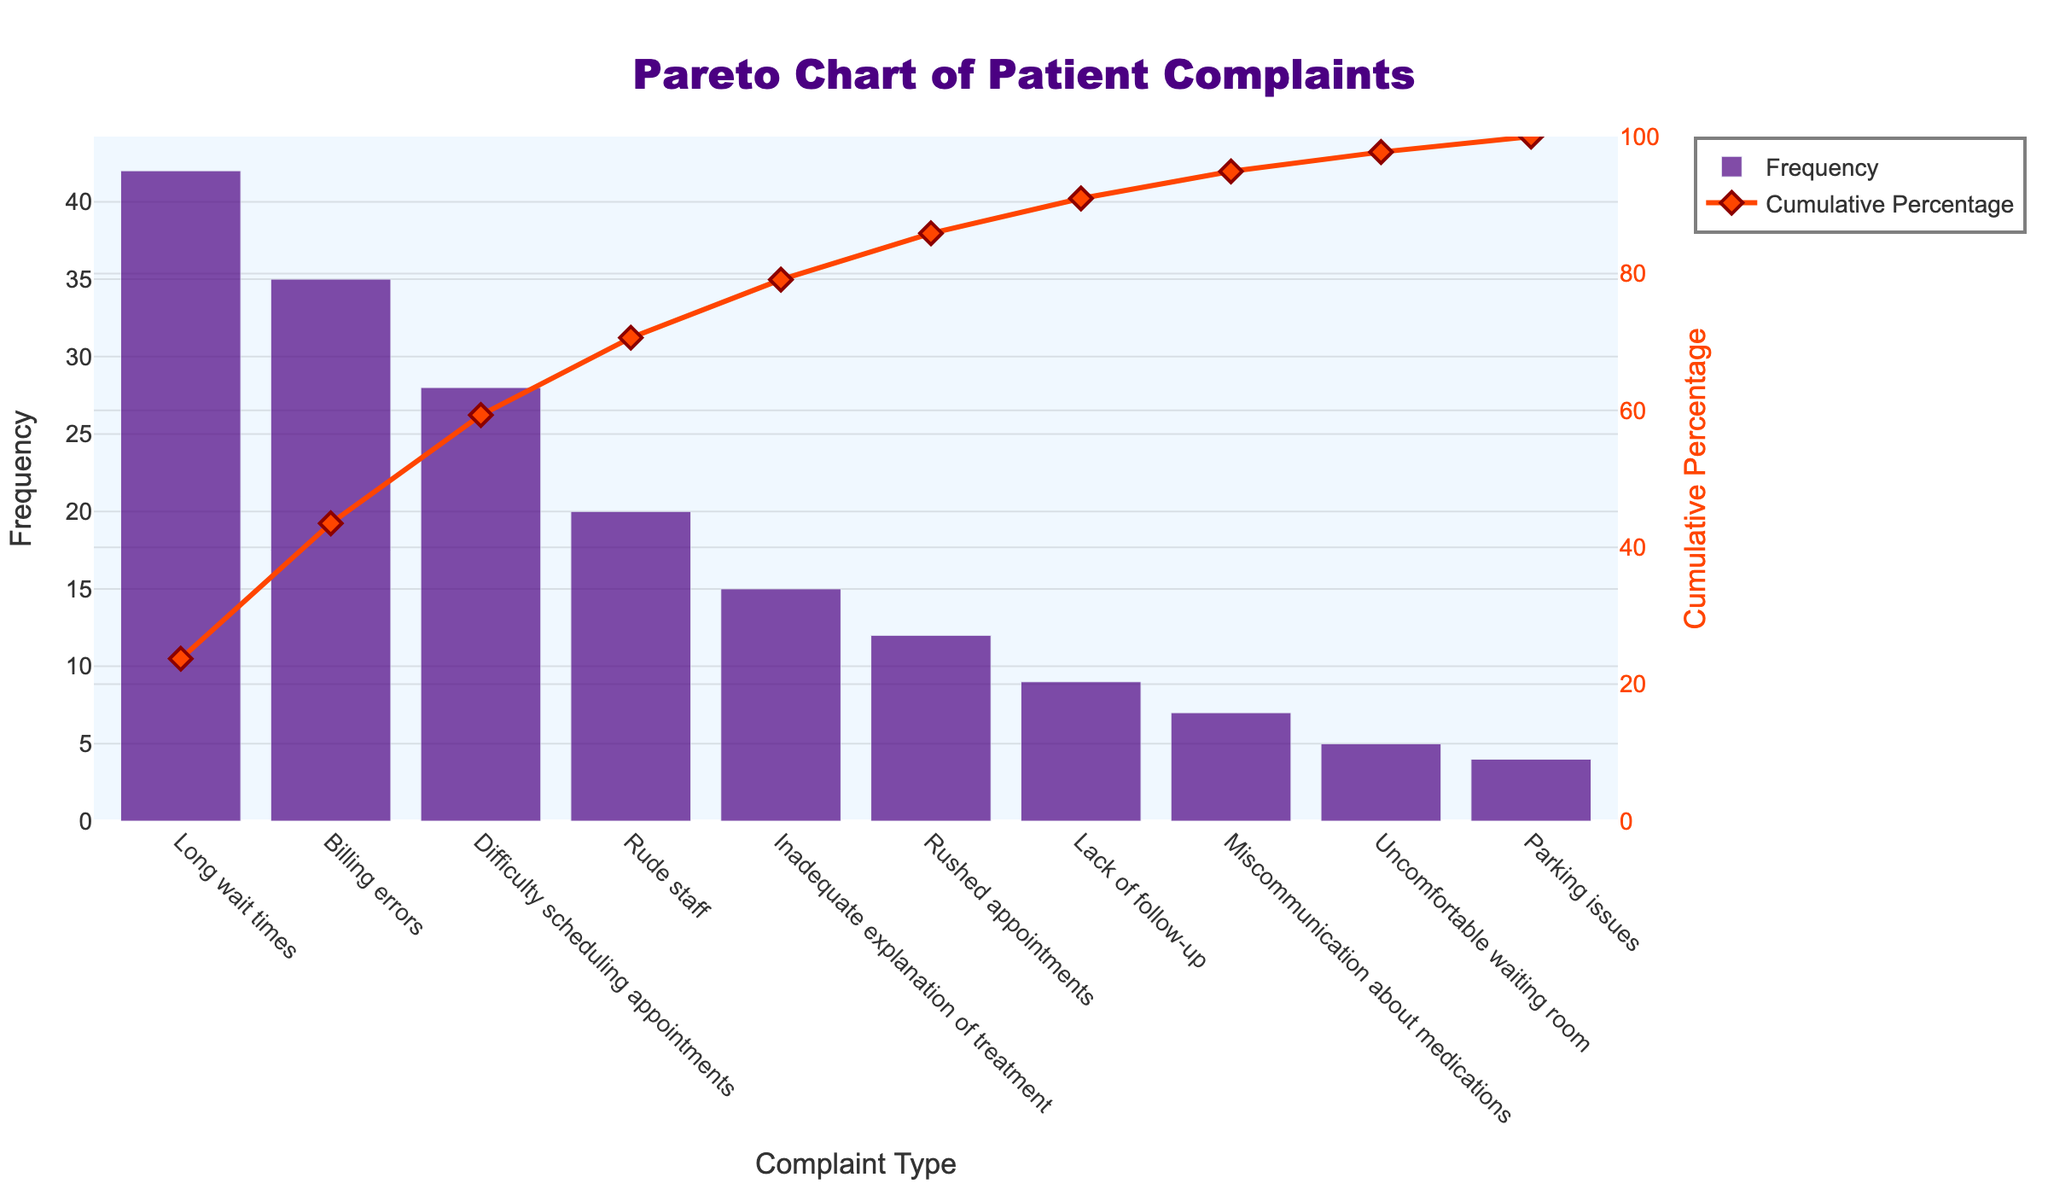What is the title of the Pareto chart? The title of a chart is typically located at the top of the figure. Here, it reads "Pareto Chart of Patient Complaints".
Answer: Pareto Chart of Patient Complaints Which complaint type has the highest frequency? The highest frequency bar is the tallest one on the left, labeled "Long wait times".
Answer: Long wait times What is the cumulative percentage for the top three complaint types combined? Add the cumulative percentages for the first three complaint types: Long wait times (33.33%), Billing errors (60%), and Difficulty scheduling appointments (80%).
Answer: 80% How many complaint types have a frequency higher than 15? From the sorted bar chart, count the number of bars with frequencies greater than 15: Long wait times, Billing errors, Difficulty scheduling appointments, and Rude staff.
Answer: 4 Which complaint type contributes to achieving a cumulative percentage of over 90%? Look at the cumulative percentage line and identify the complaint type that brings the total just over 90%. This happens at "Rushed appointments".
Answer: Rushed appointments Compare the frequency of 'Rude staff' complaints to 'Parking issues' complaints. Find and compare the heights of the bars labeled "Rude staff" and "Parking issues": Rude staff (20) is greater than Parking issues (4).
Answer: Rude staff > Parking issues What is the difference in the number of complaints between 'Long wait times' and 'Billing errors'? Subtract the frequency of Billing errors (35) from Long wait times (42): 42 - 35 = 7.
Answer: 7 What percentage of complaints are 'Rude staff'? To find the percentage, divide the frequency of 'Rude staff' (20) by the total number of complaints, then multiply by 100. Sum of all complaints frequency: 177. Thus, (20/177) * 100 ≈ 11.3%.
Answer: 11.3% Identify which complaint types collectively represent the smallest portion of the total number of complaints, making up less than 10%. Look at the cumulative percentage line and pinpoint the complaint types starting from the least frequent ones until their cumulative percentage is less than 10%. These are: Miscommunication about medications, Uncomfortable waiting room, Parking issues.
Answer: Miscommunication about medications, Uncomfortable waiting room, Parking issues 